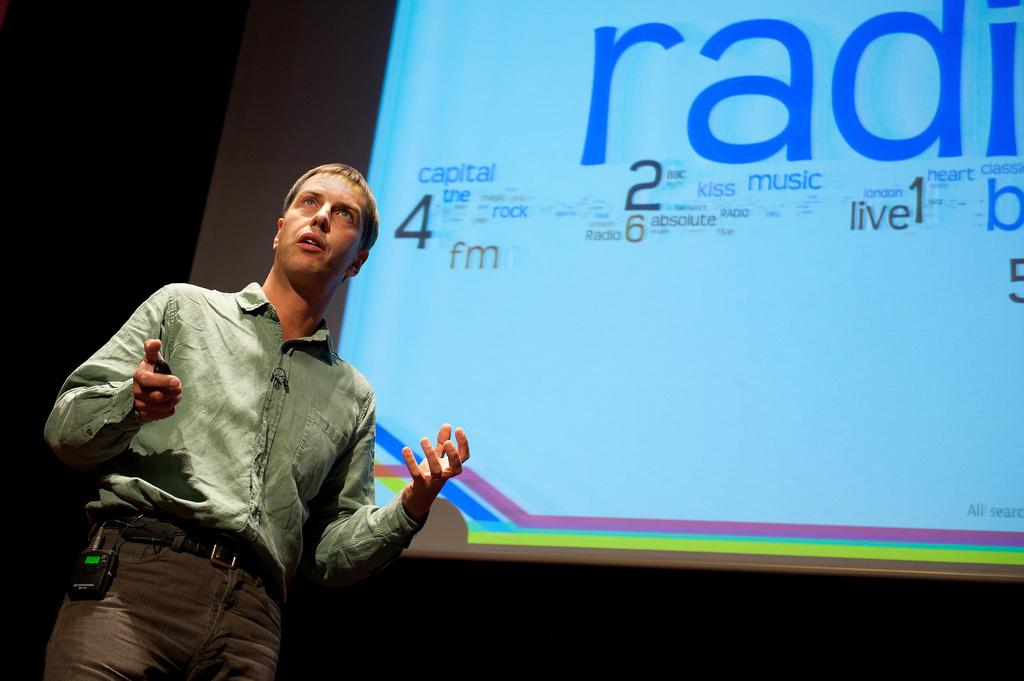Who is present in the image? There is a man in the image. What is the man wearing? The man is wearing a shirt and trousers. What can be seen behind the man in the image? The man is standing near a projector screen. How would you describe the lighting in the image? The bottom part of the image appears to be dark. What type of company is being discussed over dinner in the image? There is no dinner or company discussion present in the image; it only features a man standing near a projector screen. How does the man's digestion process appear to be affected by the image? There is no information about the man's digestion process in the image, as it only shows him standing near a projector screen. 